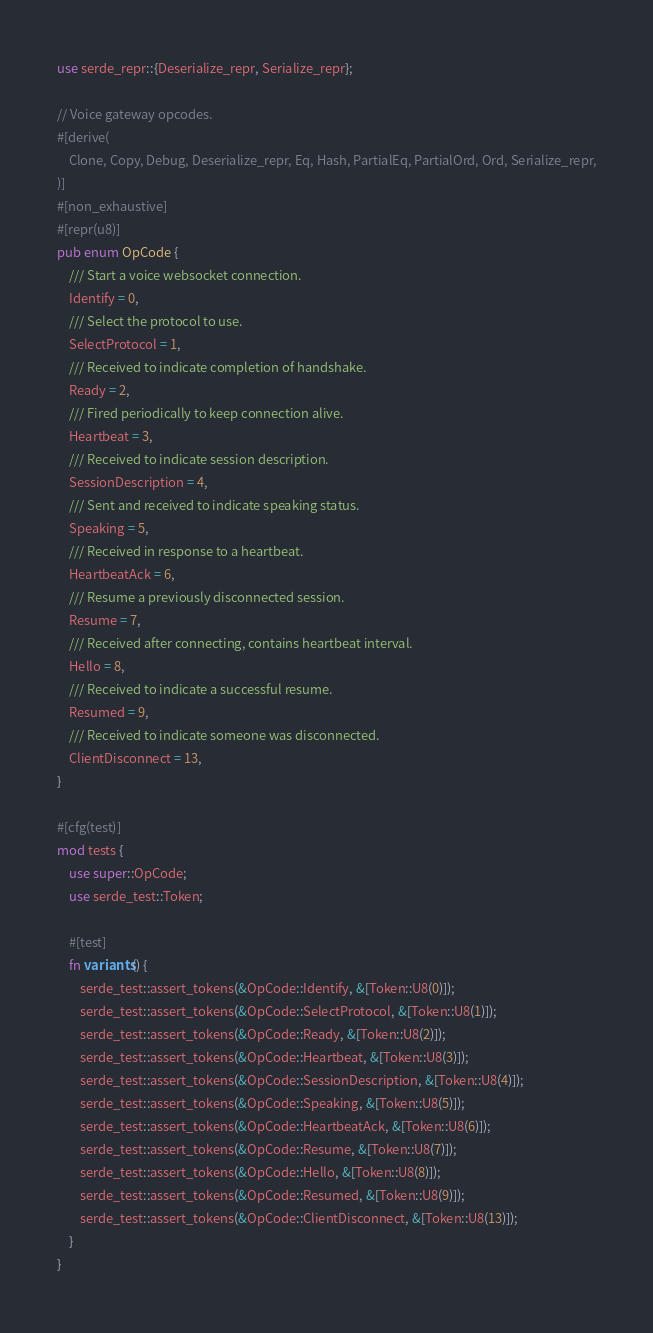<code> <loc_0><loc_0><loc_500><loc_500><_Rust_>use serde_repr::{Deserialize_repr, Serialize_repr};

// Voice gateway opcodes.
#[derive(
    Clone, Copy, Debug, Deserialize_repr, Eq, Hash, PartialEq, PartialOrd, Ord, Serialize_repr,
)]
#[non_exhaustive]
#[repr(u8)]
pub enum OpCode {
    /// Start a voice websocket connection.
    Identify = 0,
    /// Select the protocol to use.
    SelectProtocol = 1,
    /// Received to indicate completion of handshake.
    Ready = 2,
    /// Fired periodically to keep connection alive.
    Heartbeat = 3,
    /// Received to indicate session description.
    SessionDescription = 4,
    /// Sent and received to indicate speaking status.
    Speaking = 5,
    /// Received in response to a heartbeat.
    HeartbeatAck = 6,
    /// Resume a previously disconnected session.
    Resume = 7,
    /// Received after connecting, contains heartbeat interval.
    Hello = 8,
    /// Received to indicate a successful resume.
    Resumed = 9,
    /// Received to indicate someone was disconnected.
    ClientDisconnect = 13,
}

#[cfg(test)]
mod tests {
    use super::OpCode;
    use serde_test::Token;

    #[test]
    fn variants() {
        serde_test::assert_tokens(&OpCode::Identify, &[Token::U8(0)]);
        serde_test::assert_tokens(&OpCode::SelectProtocol, &[Token::U8(1)]);
        serde_test::assert_tokens(&OpCode::Ready, &[Token::U8(2)]);
        serde_test::assert_tokens(&OpCode::Heartbeat, &[Token::U8(3)]);
        serde_test::assert_tokens(&OpCode::SessionDescription, &[Token::U8(4)]);
        serde_test::assert_tokens(&OpCode::Speaking, &[Token::U8(5)]);
        serde_test::assert_tokens(&OpCode::HeartbeatAck, &[Token::U8(6)]);
        serde_test::assert_tokens(&OpCode::Resume, &[Token::U8(7)]);
        serde_test::assert_tokens(&OpCode::Hello, &[Token::U8(8)]);
        serde_test::assert_tokens(&OpCode::Resumed, &[Token::U8(9)]);
        serde_test::assert_tokens(&OpCode::ClientDisconnect, &[Token::U8(13)]);
    }
}
</code> 